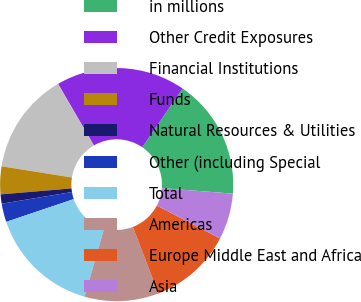Convert chart. <chart><loc_0><loc_0><loc_500><loc_500><pie_chart><fcel>in millions<fcel>Other Credit Exposures<fcel>Financial Institutions<fcel>Funds<fcel>Natural Resources & Utilities<fcel>Other (including Special<fcel>Total<fcel>Americas<fcel>Europe Middle East and Africa<fcel>Asia<nl><fcel>16.67%<fcel>17.95%<fcel>14.1%<fcel>3.85%<fcel>1.28%<fcel>2.56%<fcel>15.38%<fcel>10.26%<fcel>11.54%<fcel>6.41%<nl></chart> 